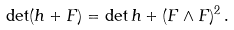<formula> <loc_0><loc_0><loc_500><loc_500>\det ( h + F ) = \det h + ( F \wedge F ) ^ { 2 } \, .</formula> 